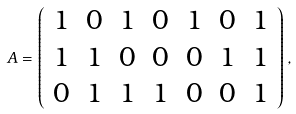Convert formula to latex. <formula><loc_0><loc_0><loc_500><loc_500>A = \left ( \begin{array} { c c c c c c c } 1 & 0 & 1 & 0 & 1 & 0 & 1 \\ 1 & 1 & 0 & 0 & 0 & 1 & 1 \\ 0 & 1 & 1 & 1 & 0 & 0 & 1 \end{array} \right ) ,</formula> 